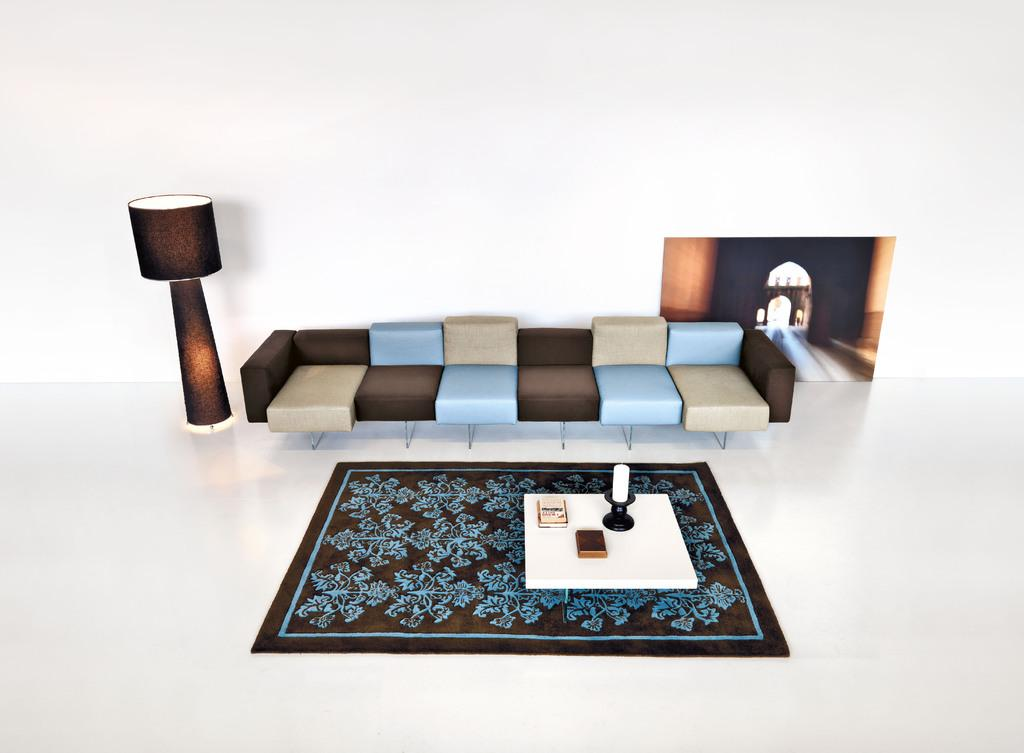What type of vehicle is in the image? There is a coach in the image. What type of lighting is present in the image? There is a lantern lamp with a stand in the image. What type of decoration is in the image? There is a poster in the image. What type of flooring is in the image? The floor has a carpet. What type of furniture is in the image? There is a table in the image. What items are on the table in the image? There is a candle and books on the table. What type of rice is being cooked on the table in the image? There is no rice present in the image; the table has a candle and books on it. How many daughters are visible in the image? There are no people, including daughters, present in the image. 